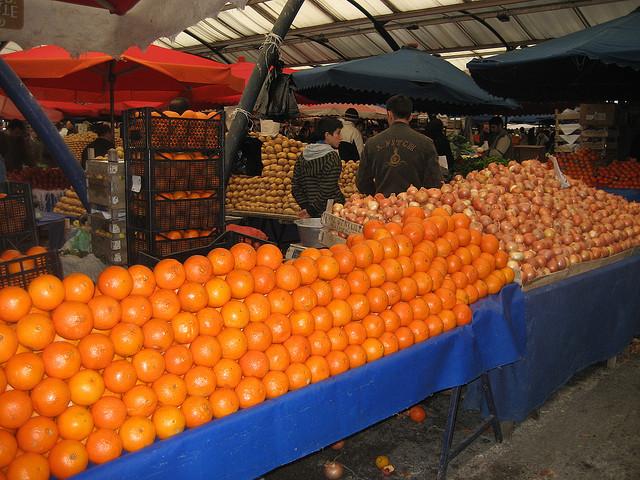Is this an indoor or outdoor market?
Short answer required. Indoor. What type of fruit is displayed at the front of the picture?
Write a very short answer. Oranges. What color are the tablecloths?
Quick response, please. Blue. What color is the canopy?
Be succinct. White. Are the lights on?
Be succinct. No. 